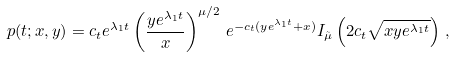Convert formula to latex. <formula><loc_0><loc_0><loc_500><loc_500>p ( t ; x , y ) = c _ { t } e ^ { \lambda _ { 1 } t } \left ( \frac { y e ^ { \lambda _ { 1 } t } } { x } \right ) ^ { \mu / 2 } \, e ^ { - c _ { t } ( y e ^ { \lambda _ { 1 } t } + x ) } I _ { \tilde { \mu } } \left ( 2 c _ { t } \sqrt { x y e ^ { \lambda _ { 1 } t } } \right ) \, ,</formula> 